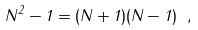Convert formula to latex. <formula><loc_0><loc_0><loc_500><loc_500>N ^ { 2 } - 1 = ( N + 1 ) ( N - 1 ) \ ,</formula> 